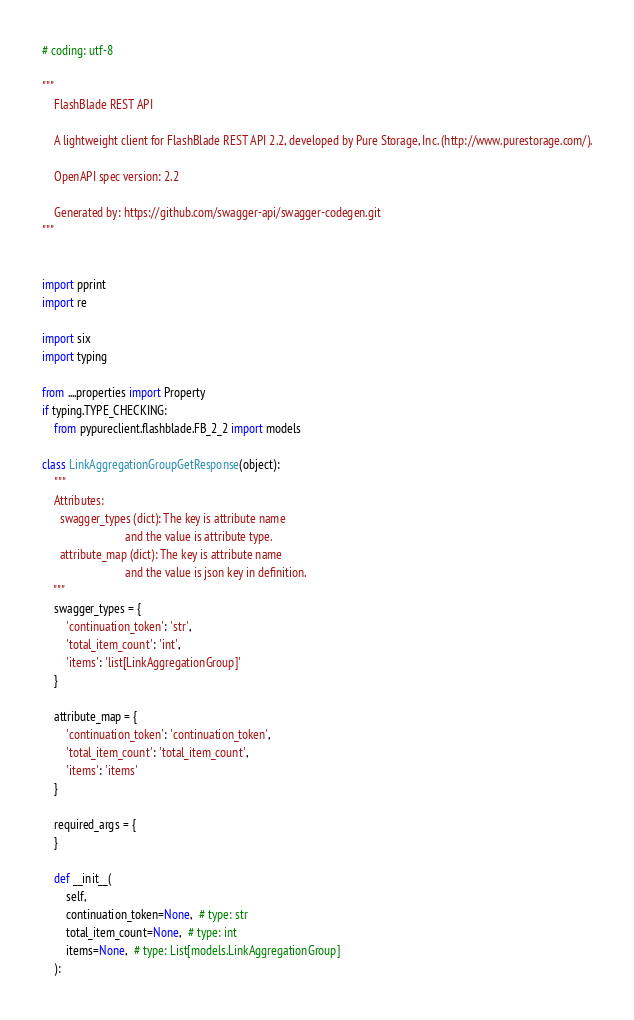<code> <loc_0><loc_0><loc_500><loc_500><_Python_># coding: utf-8

"""
    FlashBlade REST API

    A lightweight client for FlashBlade REST API 2.2, developed by Pure Storage, Inc. (http://www.purestorage.com/).

    OpenAPI spec version: 2.2
    
    Generated by: https://github.com/swagger-api/swagger-codegen.git
"""


import pprint
import re

import six
import typing

from ....properties import Property
if typing.TYPE_CHECKING:
    from pypureclient.flashblade.FB_2_2 import models

class LinkAggregationGroupGetResponse(object):
    """
    Attributes:
      swagger_types (dict): The key is attribute name
                            and the value is attribute type.
      attribute_map (dict): The key is attribute name
                            and the value is json key in definition.
    """
    swagger_types = {
        'continuation_token': 'str',
        'total_item_count': 'int',
        'items': 'list[LinkAggregationGroup]'
    }

    attribute_map = {
        'continuation_token': 'continuation_token',
        'total_item_count': 'total_item_count',
        'items': 'items'
    }

    required_args = {
    }

    def __init__(
        self,
        continuation_token=None,  # type: str
        total_item_count=None,  # type: int
        items=None,  # type: List[models.LinkAggregationGroup]
    ):</code> 